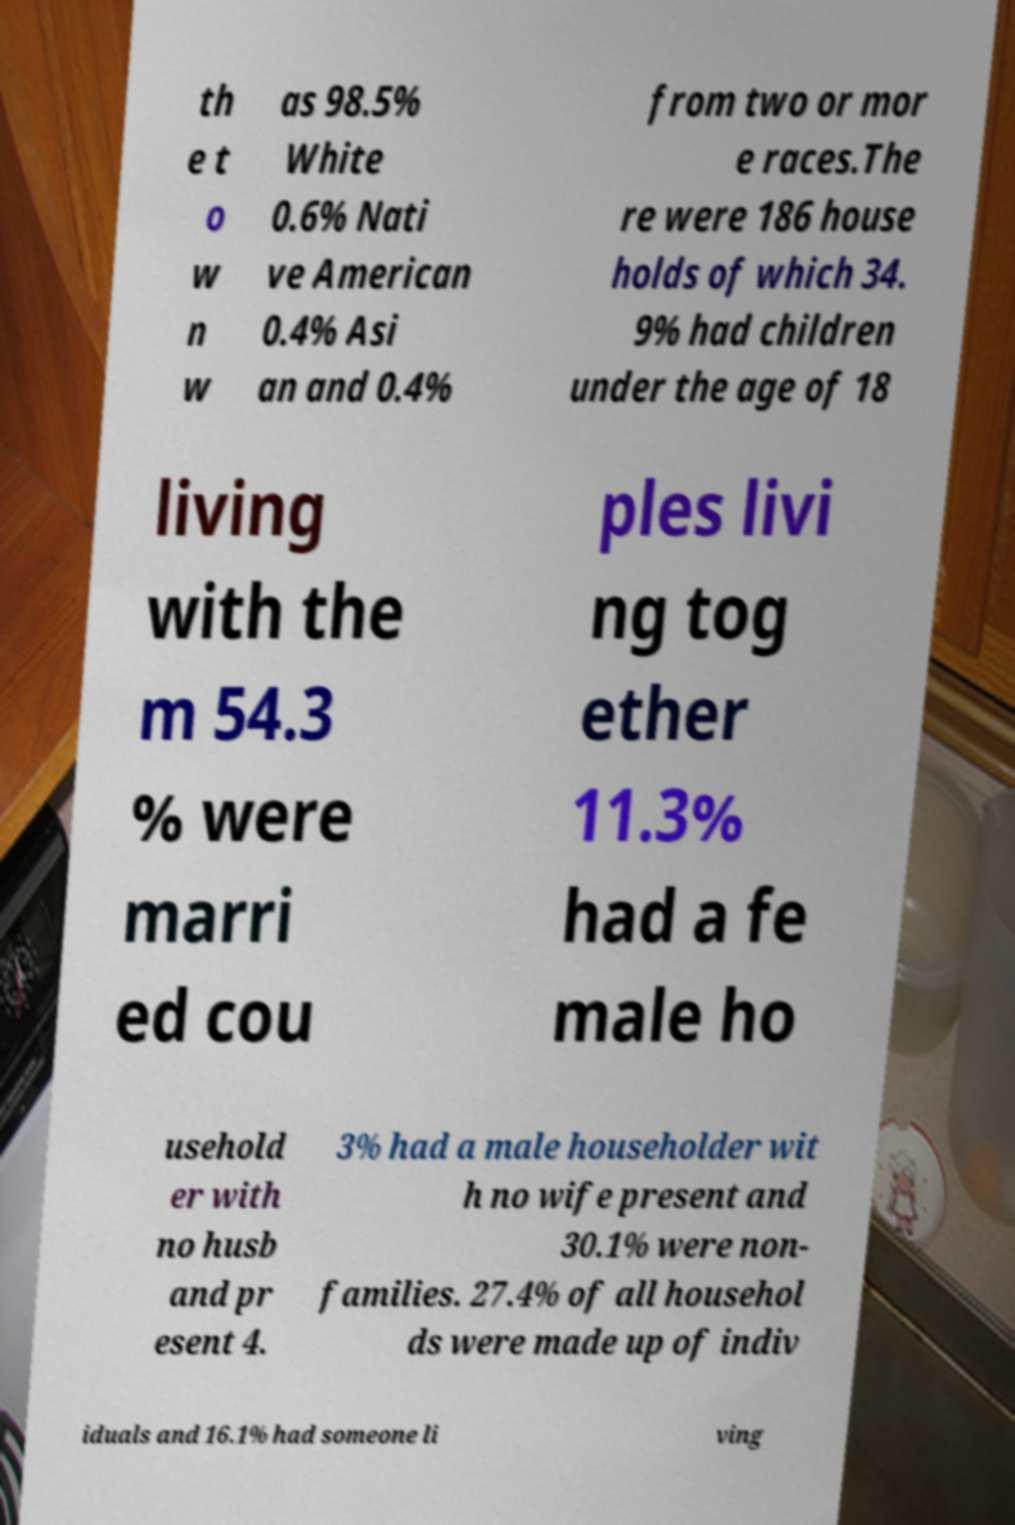What messages or text are displayed in this image? I need them in a readable, typed format. th e t o w n w as 98.5% White 0.6% Nati ve American 0.4% Asi an and 0.4% from two or mor e races.The re were 186 house holds of which 34. 9% had children under the age of 18 living with the m 54.3 % were marri ed cou ples livi ng tog ether 11.3% had a fe male ho usehold er with no husb and pr esent 4. 3% had a male householder wit h no wife present and 30.1% were non- families. 27.4% of all househol ds were made up of indiv iduals and 16.1% had someone li ving 